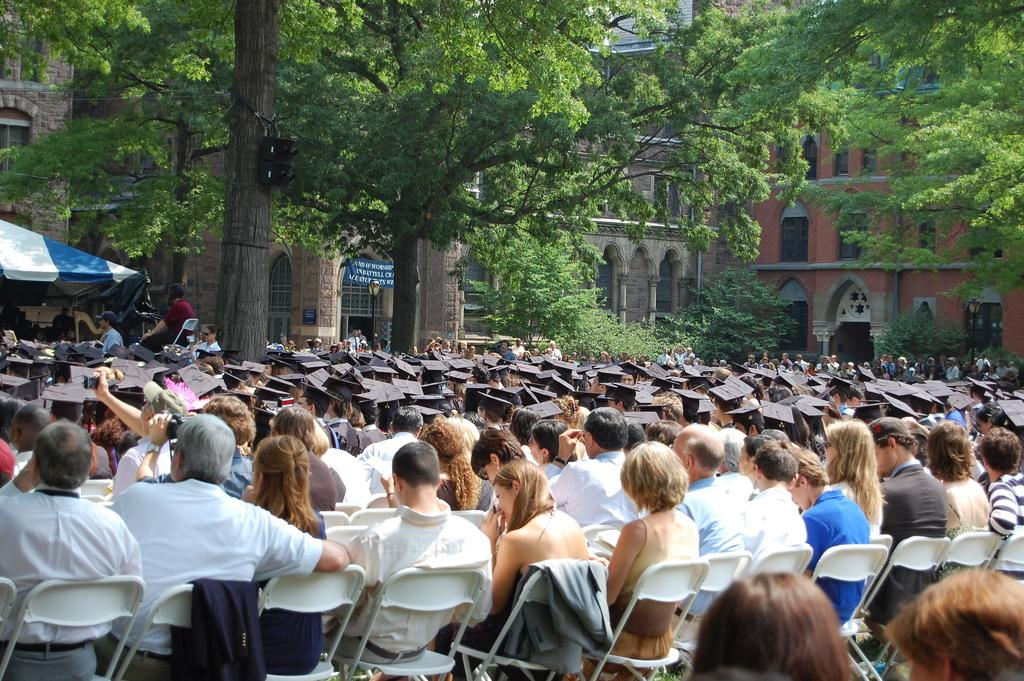How many people are in the image? There is a group of people in the image. What are the people doing in the image? The people are seated on chairs. What can be seen in the background of the image? There are buildings and trees visible in the image. What color is the crayon being used by the people in the image? There is no crayon present in the image. How does the invention in the image work? There is no invention present in the image. 